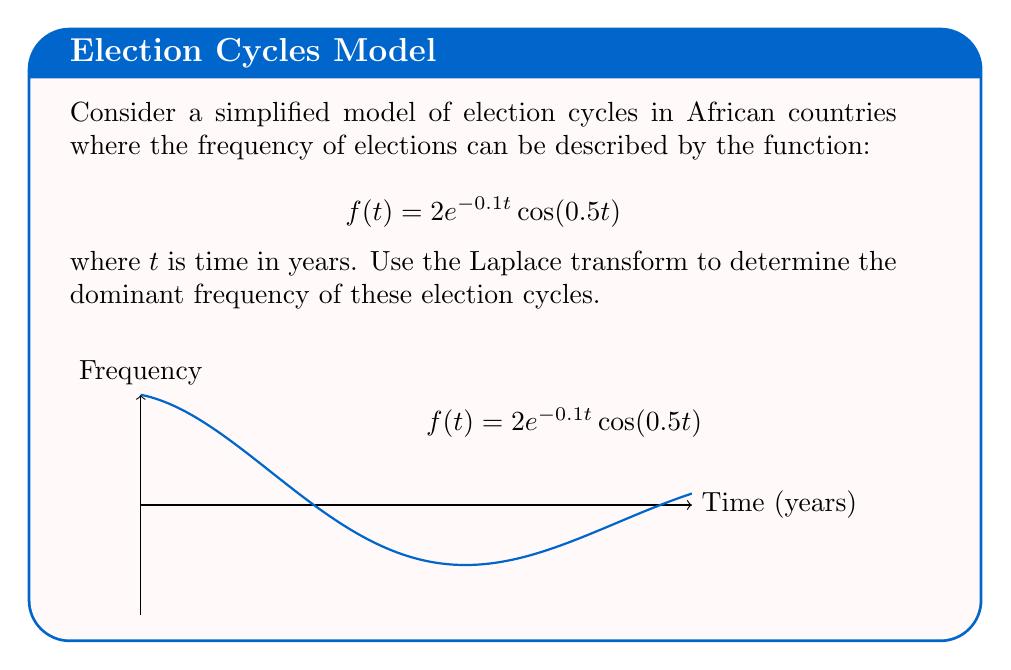Solve this math problem. To solve this problem, we'll follow these steps:

1) First, recall the Laplace transform of the given function:
   $$\mathcal{L}\{e^{at}\cos(bt)\} = \frac{s-a}{(s-a)^2 + b^2}$$

2) In our case, $a = -0.1$ and $b = 0.5$. We also have a factor of 2. So:
   $$\mathcal{L}\{2e^{-0.1t}\cos(0.5t)\} = \frac{2(s+0.1)}{(s+0.1)^2 + 0.5^2}$$

3) To find the dominant frequency, we need to find the poles of this function. The poles occur when the denominator equals zero:
   $$(s+0.1)^2 + 0.5^2 = 0$$

4) Solving this equation:
   $(s+0.1)^2 = -0.5^2$
   $s+0.1 = \pm 0.5i$
   $s = -0.1 \pm 0.5i$

5) The imaginary part of these complex poles gives us the angular frequency:
   $\omega = 0.5$ radians/year

6) To convert this to frequency in cycles per year:
   $f = \frac{\omega}{2\pi} = \frac{0.5}{2\pi} \approx 0.0796$ cycles/year

7) To express this as a period (years per cycle):
   $T = \frac{1}{f} \approx 12.57$ years
Answer: The dominant frequency is approximately 0.0796 cycles per year, or a period of about 12.57 years per cycle. 